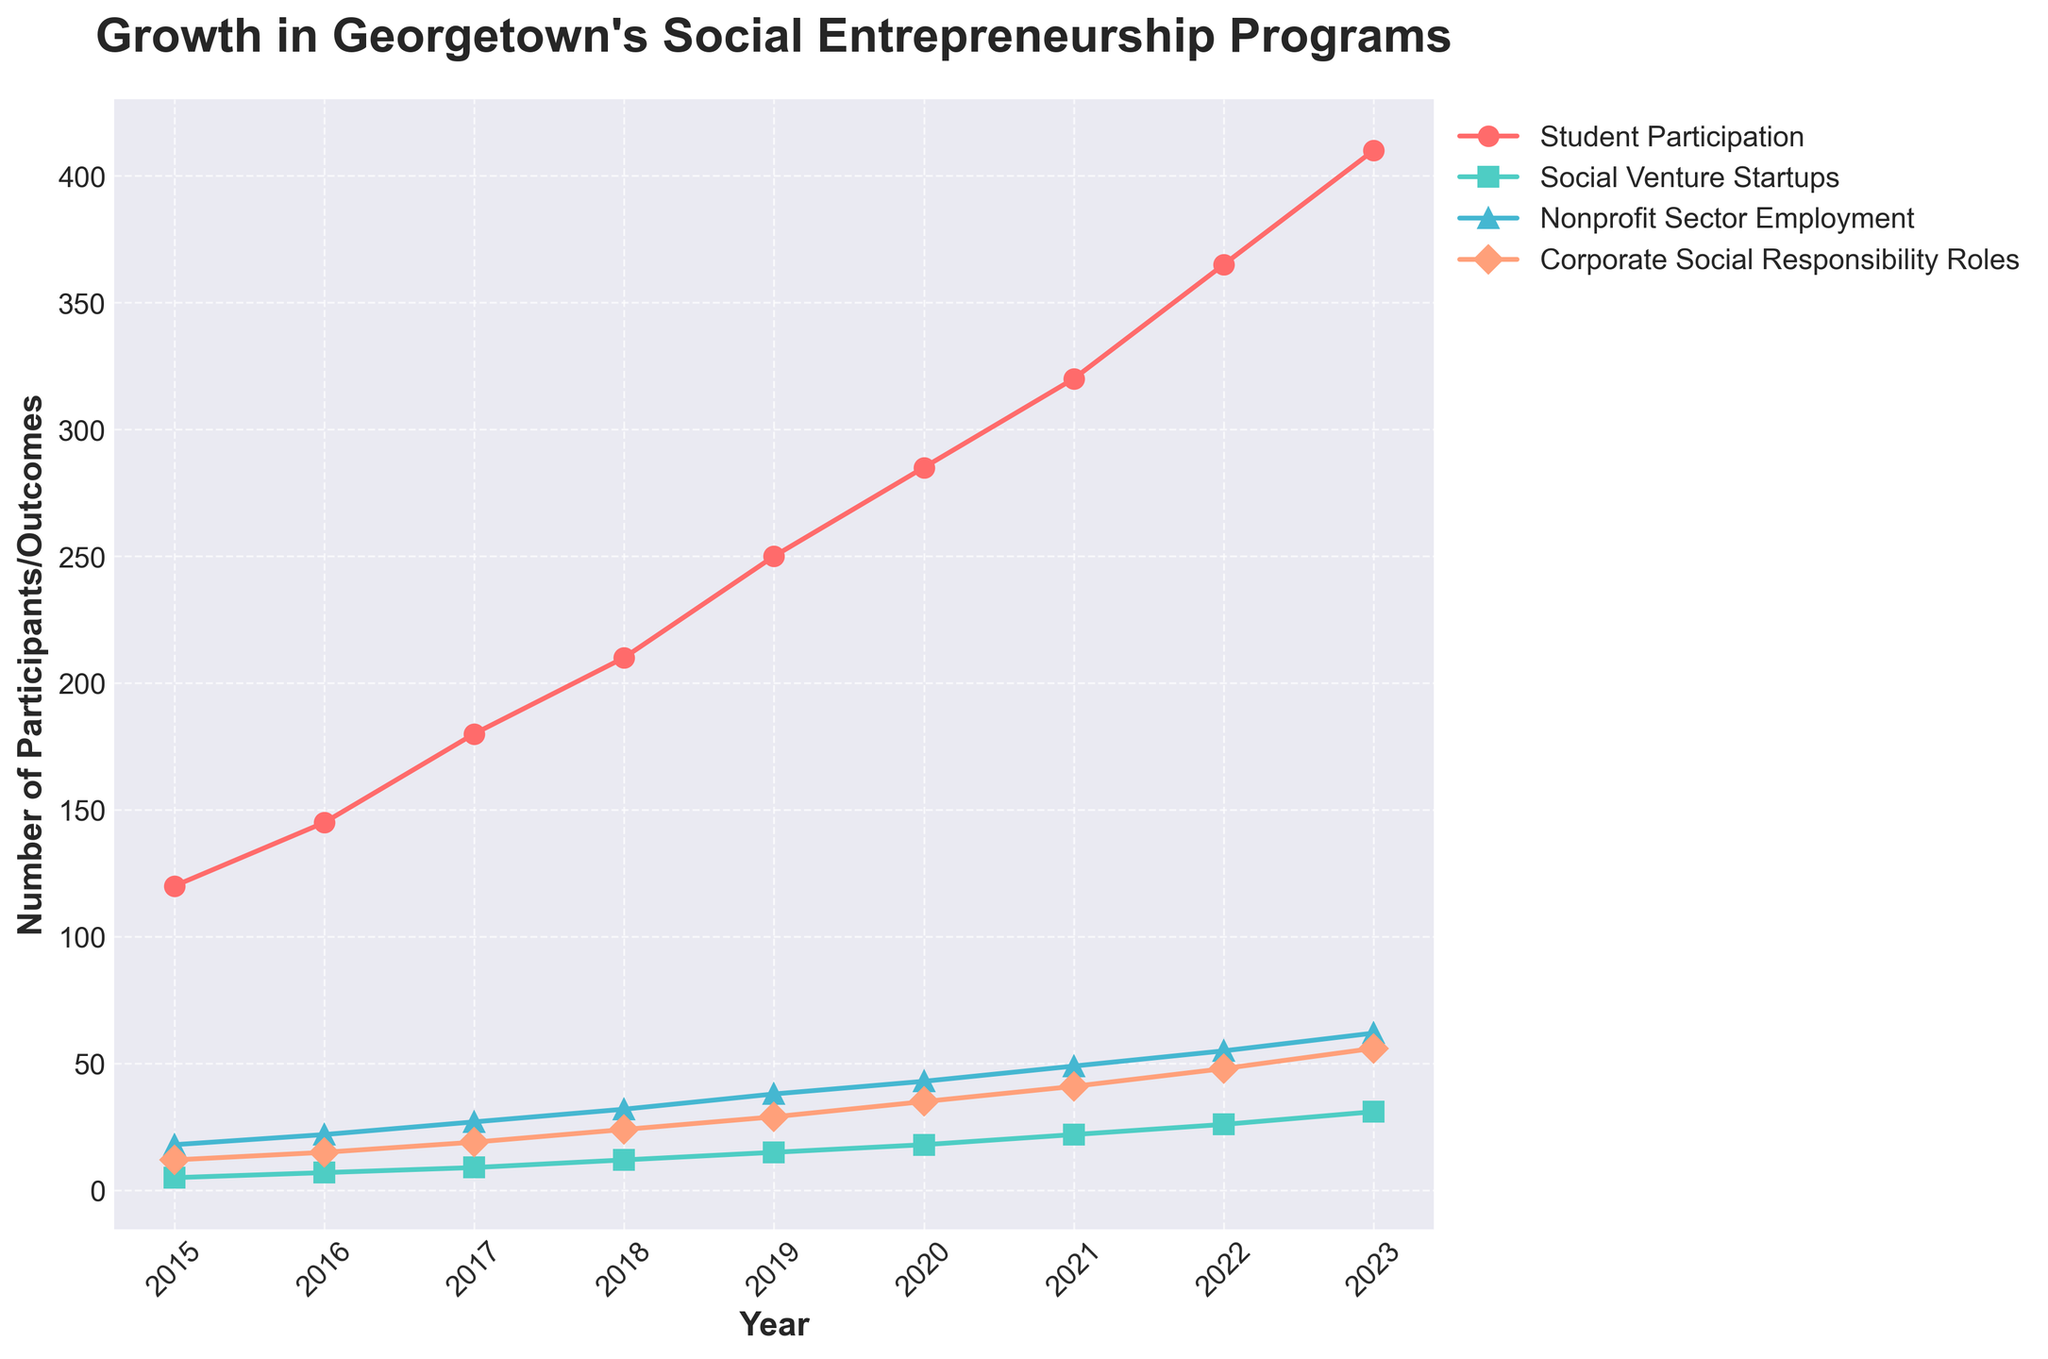How has student participation changed from 2015 to 2023? Student participation in 2015 was 120 and in 2023 it was 410. The change is 410 - 120 = 290.
Answer: 290 Which year saw the highest increase in Nonprofit Sector Employment compared to the previous year? By comparing the yearly increments, 2017 to 2018 shows an increase from 27 to 32, which is 5, higher than any other annual increase.
Answer: 2017 to 2018 Between 2019 and 2023, which metric shows the largest increase? Student Participation increases from 250 to 410 (160), Social Venture Startups from 15 to 31 (16), Nonprofit Sector Employment from 38 to 62 (24), and Corporate Social Responsibility Roles from 29 to 56 (27). Student Participation has the largest increase of 160.
Answer: Student Participation What is the trend observed in Corporate Social Responsibility Roles from 2015 to 2023? Corporate Social Responsibility Roles consistently increased each year from 12 in 2015 to 56 in 2023, indicating a positive growth trend.
Answer: Positive growth What was the average student participation from 2015 to 2023? Sum the student participation numbers from 2015 to 2023: 120 + 145 + 180 + 210 + 250 + 285 + 320 + 365 + 410 = 2285. There are 9 years, so the average is 2285 / 9 = 254.
Answer: 254 Which metric had the least change over the years? By visually comparing the slopes of the lines, Social Venture Startups had the smallest numerical increase from 5 in 2015 to 31 in 2023 (26), less than the other metrics.
Answer: Social Venture Startups What is the difference in Nonprofit Sector Employment between 2020 and 2022? Nonprofit Sector Employment in 2020 is 43 and in 2022 is 55. The difference is 55 - 43 = 12.
Answer: 12 How many Social Venture Startups were there in 2018, and how does this number compare to the total student participation in the same year? There were 12 Social Venture Startups in 2018, and student participation was 210. The ratio is 12 / 210 = 0.057 or approximately 5.7%.
Answer: 5.7% What was the growth rate in Corporate Social Responsibility Roles from 2018 to 2023? Growth from 24 in 2018 to 56 in 2023. The growth rate is calculated as (56 - 24) / 24 = 1.33, thus 133%.
Answer: 133% In which year did Student Participation first exceed 300? By examining the trend, Student Participation first exceeds 300 in 2021 with a value of 320.
Answer: 2021 